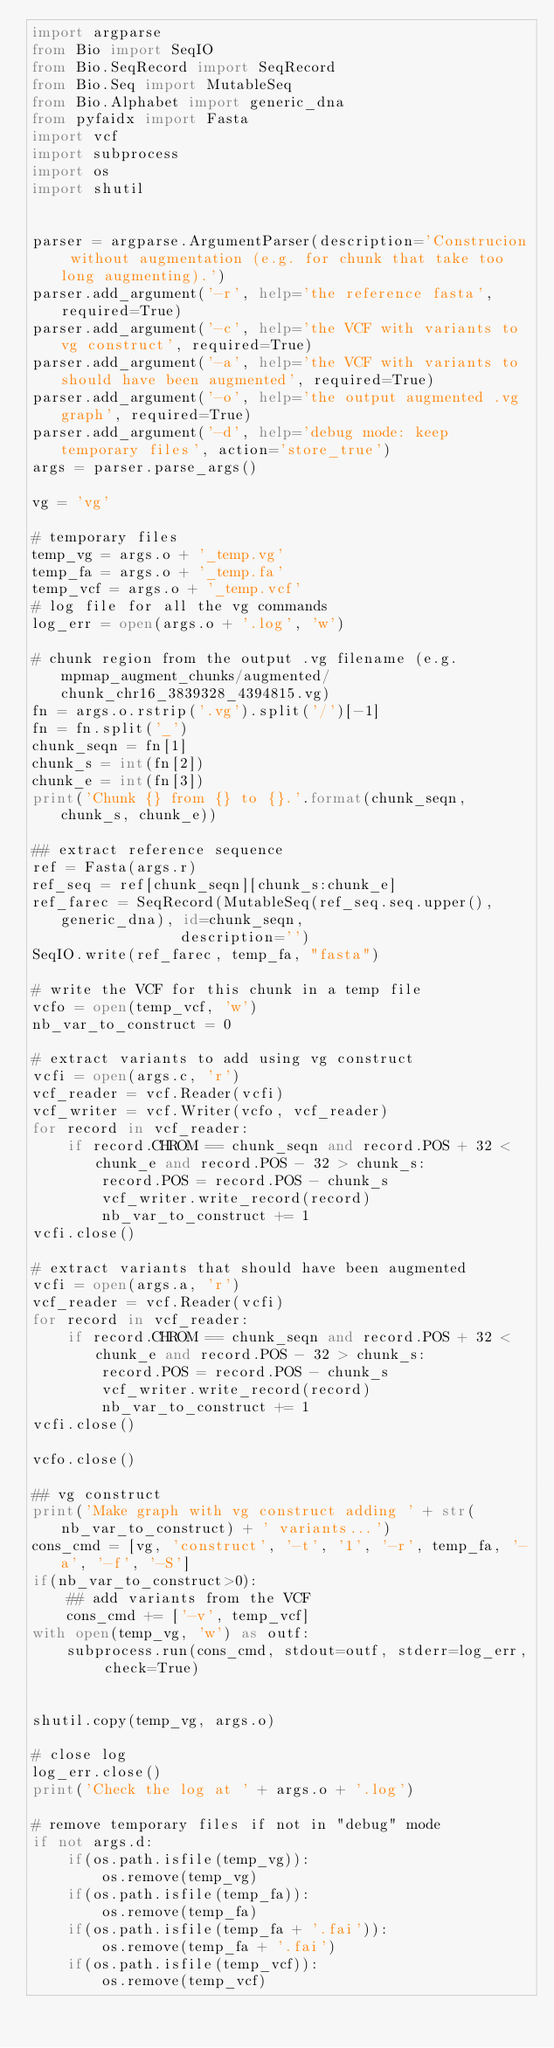Convert code to text. <code><loc_0><loc_0><loc_500><loc_500><_Python_>import argparse
from Bio import SeqIO
from Bio.SeqRecord import SeqRecord
from Bio.Seq import MutableSeq
from Bio.Alphabet import generic_dna
from pyfaidx import Fasta
import vcf
import subprocess
import os
import shutil


parser = argparse.ArgumentParser(description='Construcion without augmentation (e.g. for chunk that take too long augmenting).')
parser.add_argument('-r', help='the reference fasta', required=True)
parser.add_argument('-c', help='the VCF with variants to vg construct', required=True)
parser.add_argument('-a', help='the VCF with variants to should have been augmented', required=True)
parser.add_argument('-o', help='the output augmented .vg graph', required=True)
parser.add_argument('-d', help='debug mode: keep temporary files', action='store_true')
args = parser.parse_args()

vg = 'vg'

# temporary files
temp_vg = args.o + '_temp.vg'
temp_fa = args.o + '_temp.fa'
temp_vcf = args.o + '_temp.vcf'
# log file for all the vg commands
log_err = open(args.o + '.log', 'w')

# chunk region from the output .vg filename (e.g. mpmap_augment_chunks/augmented/chunk_chr16_3839328_4394815.vg)
fn = args.o.rstrip('.vg').split('/')[-1]
fn = fn.split('_')
chunk_seqn = fn[1]
chunk_s = int(fn[2])
chunk_e = int(fn[3])
print('Chunk {} from {} to {}.'.format(chunk_seqn, chunk_s, chunk_e))

## extract reference sequence
ref = Fasta(args.r)
ref_seq = ref[chunk_seqn][chunk_s:chunk_e]
ref_farec = SeqRecord(MutableSeq(ref_seq.seq.upper(), generic_dna), id=chunk_seqn,
                 description='')
SeqIO.write(ref_farec, temp_fa, "fasta")

# write the VCF for this chunk in a temp file
vcfo = open(temp_vcf, 'w')
nb_var_to_construct = 0

# extract variants to add using vg construct
vcfi = open(args.c, 'r')
vcf_reader = vcf.Reader(vcfi)
vcf_writer = vcf.Writer(vcfo, vcf_reader)
for record in vcf_reader:
    if record.CHROM == chunk_seqn and record.POS + 32 < chunk_e and record.POS - 32 > chunk_s:
        record.POS = record.POS - chunk_s
        vcf_writer.write_record(record)
        nb_var_to_construct += 1
vcfi.close()

# extract variants that should have been augmented
vcfi = open(args.a, 'r')
vcf_reader = vcf.Reader(vcfi)
for record in vcf_reader:
    if record.CHROM == chunk_seqn and record.POS + 32 < chunk_e and record.POS - 32 > chunk_s:
        record.POS = record.POS - chunk_s
        vcf_writer.write_record(record)
        nb_var_to_construct += 1
vcfi.close()

vcfo.close()

## vg construct
print('Make graph with vg construct adding ' + str(nb_var_to_construct) + ' variants...')
cons_cmd = [vg, 'construct', '-t', '1', '-r', temp_fa, '-a', '-f', '-S']
if(nb_var_to_construct>0):
    ## add variants from the VCF
    cons_cmd += ['-v', temp_vcf]
with open(temp_vg, 'w') as outf:
    subprocess.run(cons_cmd, stdout=outf, stderr=log_err, check=True)


shutil.copy(temp_vg, args.o)

# close log
log_err.close()
print('Check the log at ' + args.o + '.log')

# remove temporary files if not in "debug" mode
if not args.d:
    if(os.path.isfile(temp_vg)):
        os.remove(temp_vg)
    if(os.path.isfile(temp_fa)):
        os.remove(temp_fa)
    if(os.path.isfile(temp_fa + '.fai')):
        os.remove(temp_fa + '.fai')
    if(os.path.isfile(temp_vcf)):
        os.remove(temp_vcf)
</code> 